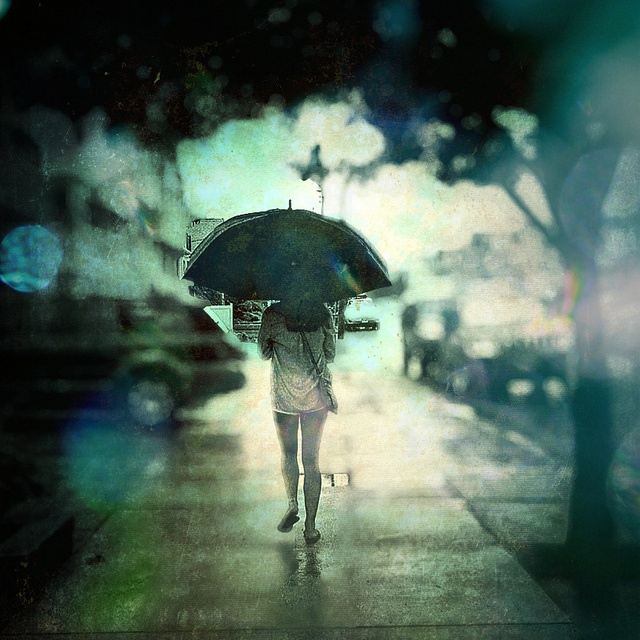Describe the objects in this image and their specific colors. I can see car in teal, black, and darkgreen tones, umbrella in teal, black, and darkgreen tones, people in teal, gray, black, darkgray, and darkgreen tones, car in teal and beige tones, and car in teal, beige, and darkgray tones in this image. 